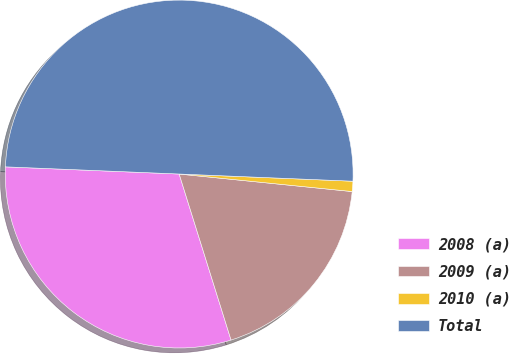Convert chart to OTSL. <chart><loc_0><loc_0><loc_500><loc_500><pie_chart><fcel>2008 (a)<fcel>2009 (a)<fcel>2010 (a)<fcel>Total<nl><fcel>30.48%<fcel>18.57%<fcel>0.95%<fcel>50.0%<nl></chart> 